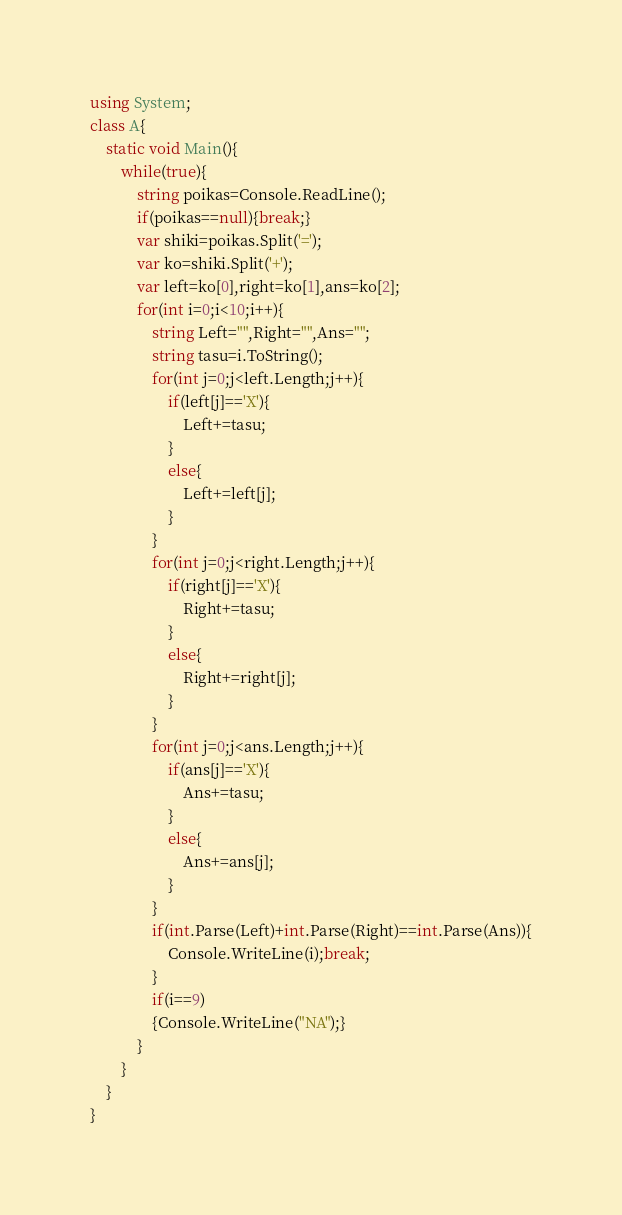<code> <loc_0><loc_0><loc_500><loc_500><_C#_>using System;
class A{
    static void Main(){
        while(true){
            string poikas=Console.ReadLine();
            if(poikas==null){break;}
            var shiki=poikas.Split('=');
            var ko=shiki.Split('+');
            var left=ko[0],right=ko[1],ans=ko[2];
            for(int i=0;i<10;i++){
                string Left="",Right="",Ans="";
                string tasu=i.ToString();
                for(int j=0;j<left.Length;j++){
                    if(left[j]=='X'){
                        Left+=tasu;
                    }
                    else{
                        Left+=left[j];
                    }
                }
                for(int j=0;j<right.Length;j++){
                    if(right[j]=='X'){
                        Right+=tasu;
                    }
                    else{
                        Right+=right[j];
                    }
                }
                for(int j=0;j<ans.Length;j++){
                    if(ans[j]=='X'){
                        Ans+=tasu;
                    }
                    else{
                        Ans+=ans[j];
                    }
                }
                if(int.Parse(Left)+int.Parse(Right)==int.Parse(Ans)){
                    Console.WriteLine(i);break;
                }
                if(i==9)
                {Console.WriteLine("NA");}                
            }
        }
    }
}
</code> 